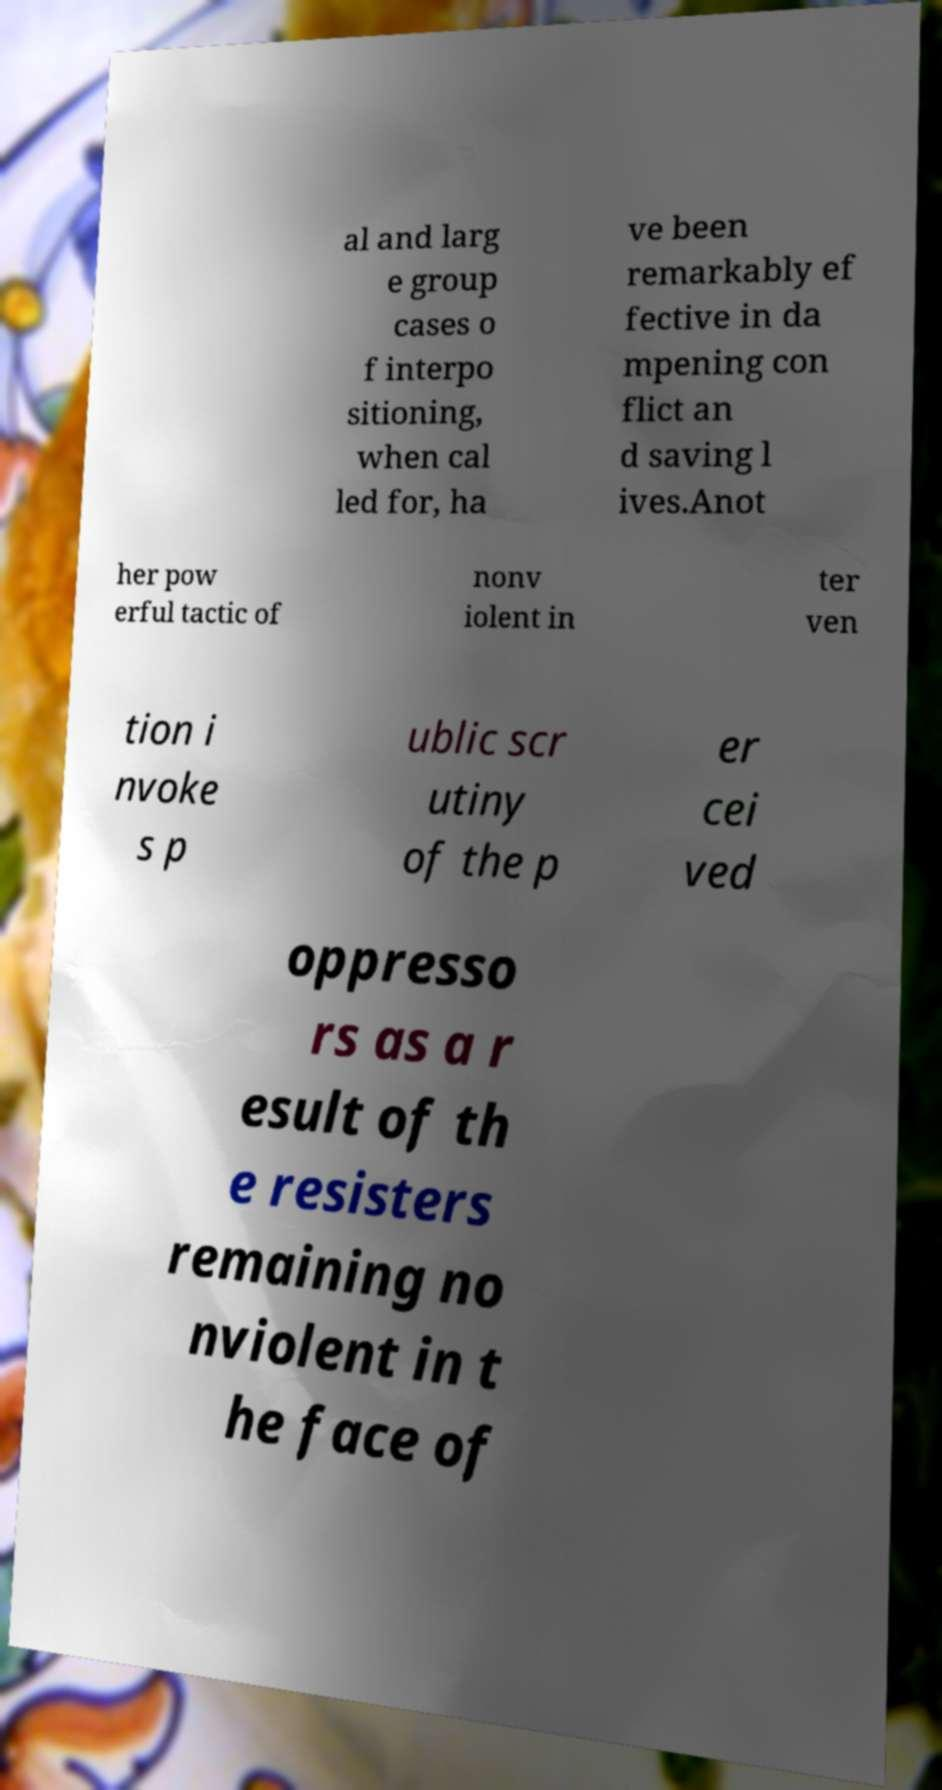Can you read and provide the text displayed in the image?This photo seems to have some interesting text. Can you extract and type it out for me? al and larg e group cases o f interpo sitioning, when cal led for, ha ve been remarkably ef fective in da mpening con flict an d saving l ives.Anot her pow erful tactic of nonv iolent in ter ven tion i nvoke s p ublic scr utiny of the p er cei ved oppresso rs as a r esult of th e resisters remaining no nviolent in t he face of 